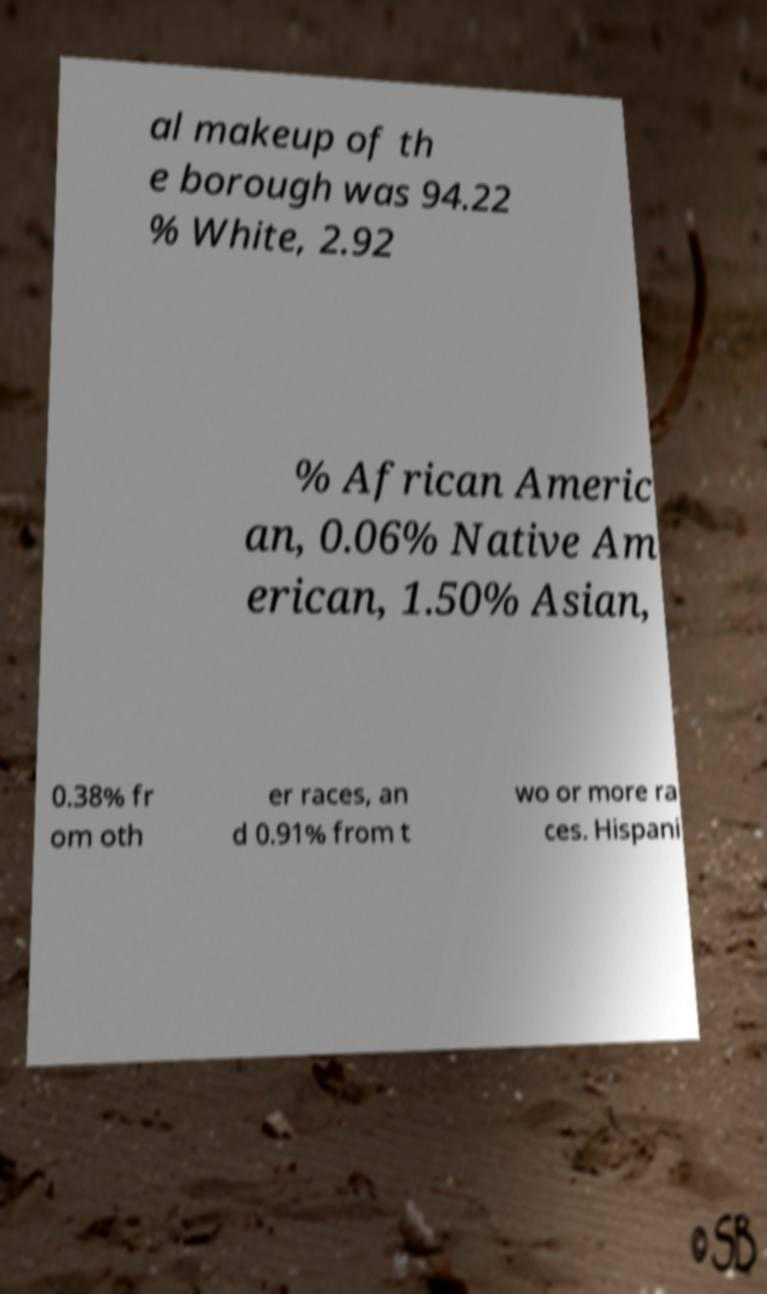For documentation purposes, I need the text within this image transcribed. Could you provide that? al makeup of th e borough was 94.22 % White, 2.92 % African Americ an, 0.06% Native Am erican, 1.50% Asian, 0.38% fr om oth er races, an d 0.91% from t wo or more ra ces. Hispani 